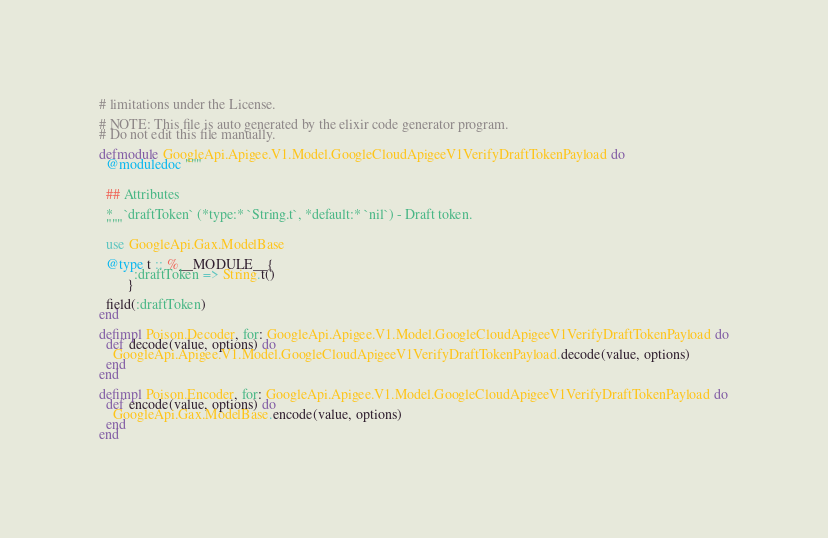Convert code to text. <code><loc_0><loc_0><loc_500><loc_500><_Elixir_># limitations under the License.

# NOTE: This file is auto generated by the elixir code generator program.
# Do not edit this file manually.

defmodule GoogleApi.Apigee.V1.Model.GoogleCloudApigeeV1VerifyDraftTokenPayload do
  @moduledoc """


  ## Attributes

  *   `draftToken` (*type:* `String.t`, *default:* `nil`) - Draft token.
  """

  use GoogleApi.Gax.ModelBase

  @type t :: %__MODULE__{
          :draftToken => String.t()
        }

  field(:draftToken)
end

defimpl Poison.Decoder, for: GoogleApi.Apigee.V1.Model.GoogleCloudApigeeV1VerifyDraftTokenPayload do
  def decode(value, options) do
    GoogleApi.Apigee.V1.Model.GoogleCloudApigeeV1VerifyDraftTokenPayload.decode(value, options)
  end
end

defimpl Poison.Encoder, for: GoogleApi.Apigee.V1.Model.GoogleCloudApigeeV1VerifyDraftTokenPayload do
  def encode(value, options) do
    GoogleApi.Gax.ModelBase.encode(value, options)
  end
end
</code> 